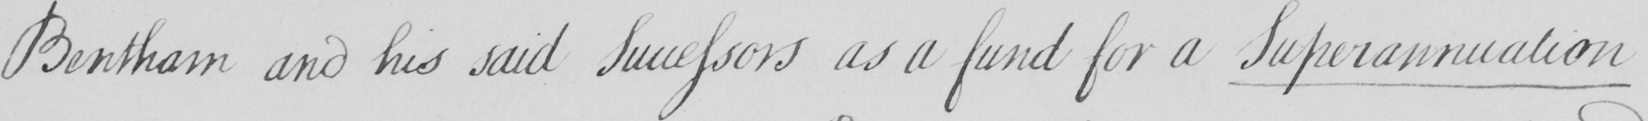What is written in this line of handwriting? Bentham and his said successors as a fund for a Superannuation 